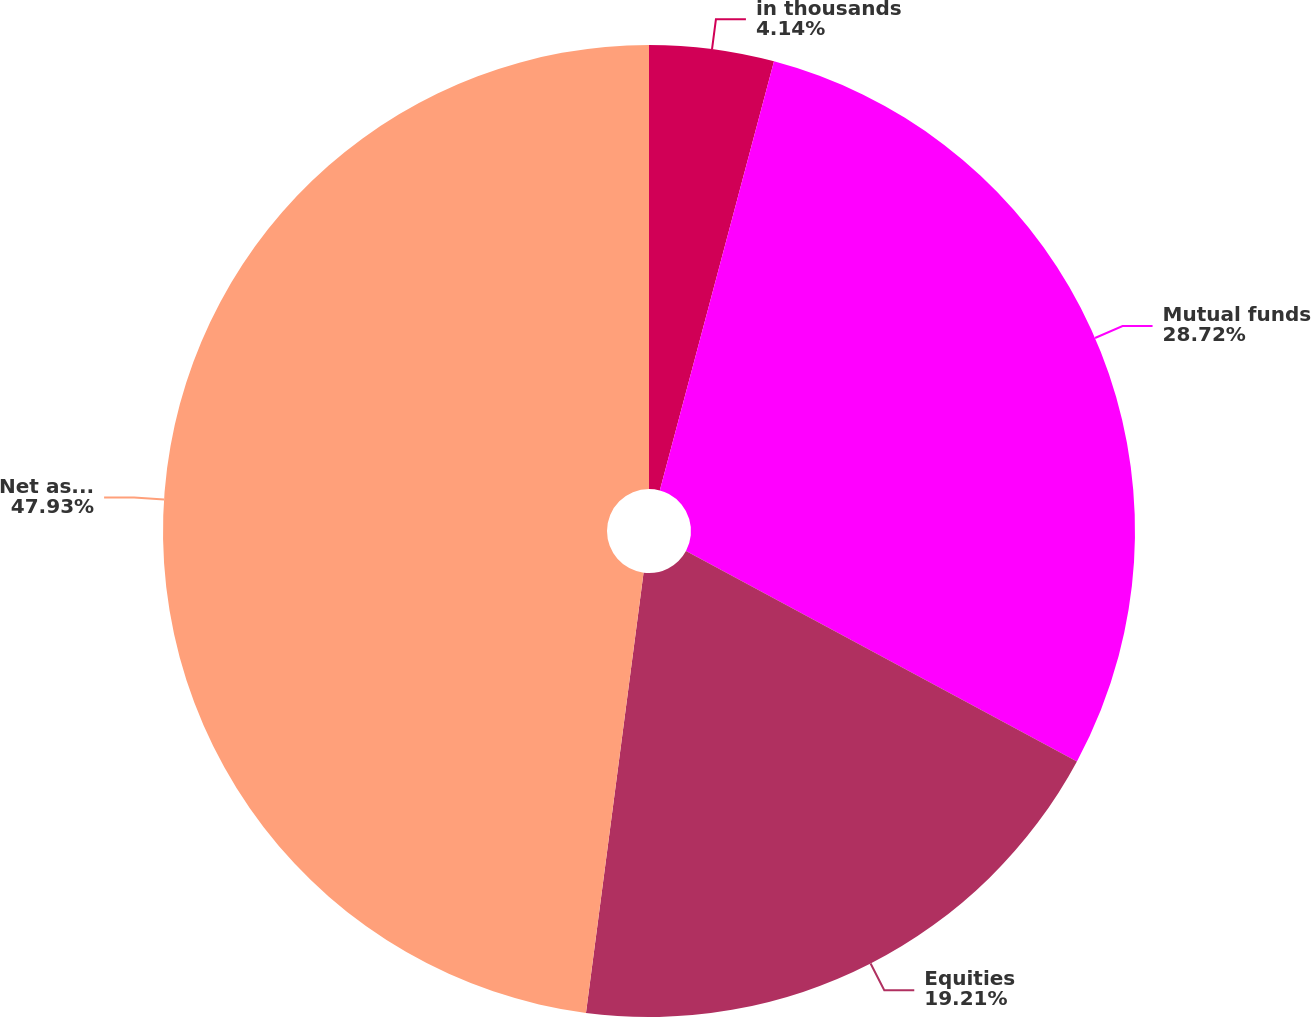Convert chart. <chart><loc_0><loc_0><loc_500><loc_500><pie_chart><fcel>in thousands<fcel>Mutual funds<fcel>Equities<fcel>Net asset<nl><fcel>4.14%<fcel>28.72%<fcel>19.21%<fcel>47.93%<nl></chart> 